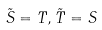<formula> <loc_0><loc_0><loc_500><loc_500>\tilde { S } = T , \tilde { T } = S</formula> 